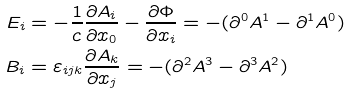Convert formula to latex. <formula><loc_0><loc_0><loc_500><loc_500>E _ { i } & = - \frac { 1 } { c } \frac { \partial A _ { i } } { \partial x _ { 0 } } - \frac { \partial \Phi } { \partial x _ { i } } = - ( \partial ^ { 0 } A ^ { 1 } - \partial ^ { 1 } A ^ { 0 } ) \\ B _ { i } & = \varepsilon _ { i j k } \frac { \partial A _ { k } } { \partial x _ { j } } = - ( \partial ^ { 2 } A ^ { 3 } - \partial ^ { 3 } A ^ { 2 } )</formula> 